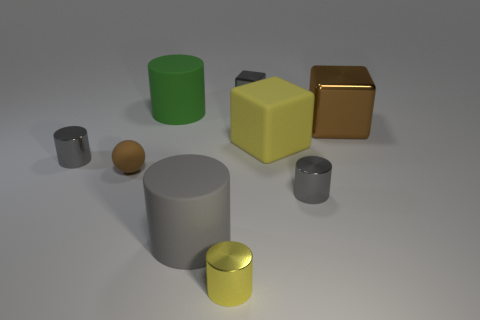How many large yellow rubber things are the same shape as the brown metal thing?
Provide a short and direct response. 1. How many objects are either tiny metallic cylinders or yellow cylinders in front of the big gray rubber cylinder?
Make the answer very short. 3. Does the tiny metallic cube have the same color as the tiny thing right of the gray cube?
Your answer should be very brief. Yes. There is a matte object that is right of the big green matte object and to the left of the yellow metal cylinder; what is its size?
Your answer should be compact. Large. There is a green rubber cylinder; are there any cylinders left of it?
Provide a succinct answer. Yes. There is a large rubber cylinder that is in front of the yellow cube; is there a cube that is in front of it?
Your answer should be very brief. No. Is the number of big brown cubes right of the brown metal block the same as the number of large cylinders to the left of the brown rubber object?
Keep it short and to the point. Yes. There is another cube that is the same material as the large brown block; what color is it?
Offer a terse response. Gray. Is there a large gray cylinder that has the same material as the big green object?
Your answer should be very brief. Yes. What number of objects are yellow matte cubes or big brown shiny blocks?
Give a very brief answer. 2. 